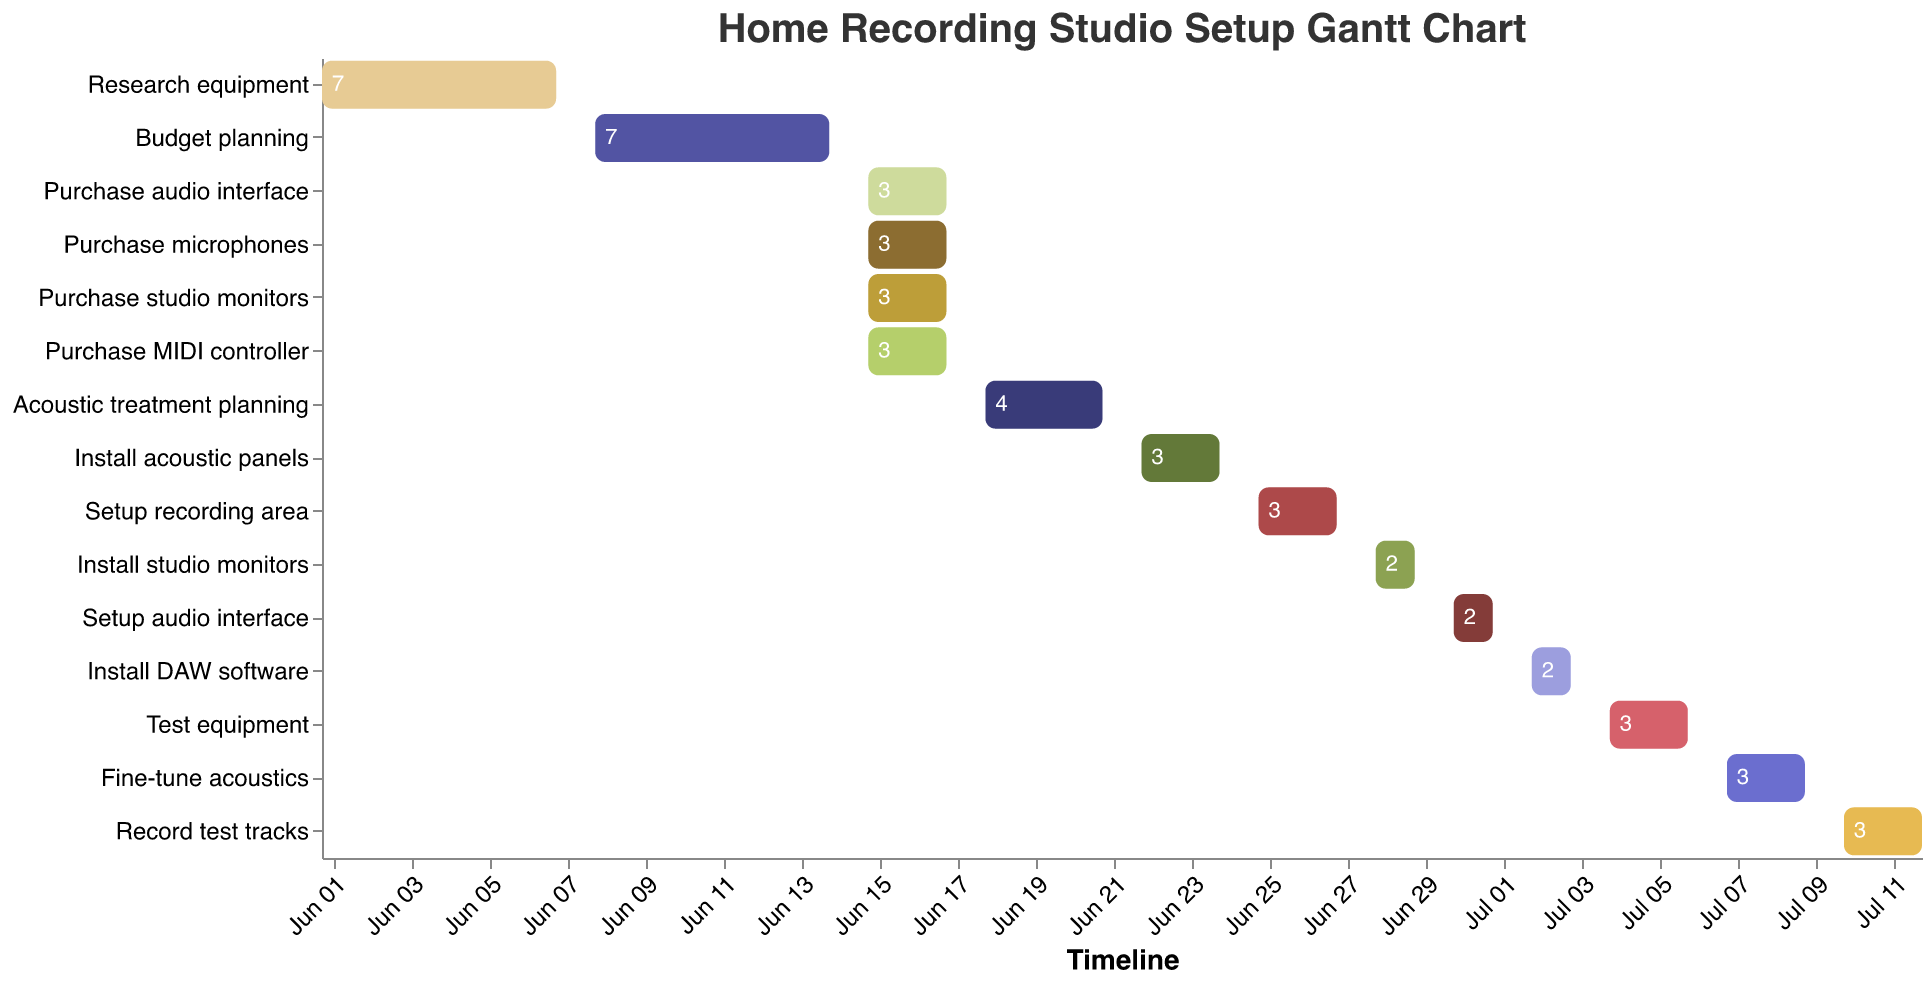How many tasks are scheduled on June 15, 2023? Look for tasks that have a start date of June 15, 2023. There are four tasks with this start date: "Purchase audio interface," "Purchase microphones," "Purchase studio monitors," and "Purchase MIDI controller."
Answer: 4 When does the "Install DAW software" task end? Check the end date for the task labeled "Install DAW software." The end date is July 3, 2023.
Answer: July 3, 2023 Which task has the shortest duration? Identify the task with the smallest duration value. The task "Install studio monitors" and "Setup audio interface" both have the shortest duration of 2 days.
Answer: Install studio monitors, Setup audio interface Which task immediately follows "Research equipment"? Check the start date of the tasks and find the one that starts right after the end date of "Research equipment," which is June 7, 2023. The task "Budget planning" starts immediately after on June 8, 2023.
Answer: Budget planning What is the total duration for setting up the recording area, including all related tasks? Add the durations of "Setup recording area," "Install studio monitors," and "Setup audio interface," which are 3, 2, and 2 days, respectively. 3 + 2 + 2 = 7 days.
Answer: 7 days Which tasks overlap with the "Acoustic treatment planning" task? Identify tasks whose timeframes overlap with the "Acoustic treatment planning" dates of June 18 to June 21. None of the tasks entirely overlap with this period, except for "Install acoustic panels," which starts immediately after on June 22.
Answer: None How many days after the start of "Budget planning" does the "Purchase studio monitors" task begin? "Budget planning" starts on June 8, and "Purchase studio monitors" start on June 15. The difference is 7 days.
Answer: 7 days Are there any tasks that extend into July? If so, which ones? Check if any task's end date is in July. "Setup audio interface," "Install DAW software," "Test equipment," "Fine-tune acoustics," and "Record test tracks" all extend into July.
Answer: Setup audio interface, Install DAW software, Test equipment, Fine-tune acoustics, Record test tracks What is the duration of the "Test equipment" task relative to the "Setup audio interface" task? Find the durations of "Test equipment" (3 days) and "Setup audio interface" (2 days) and compare them. The duration of "Test equipment" is 1 day longer than "Setup audio interface."
Answer: 1 day longer Which tasks are scheduled during the final week of June (June 24-30)? Identify tasks whose timeframes overlap with June 24-30. "Setup recording area," "Install studio monitors," and "Setup audio interface" are scheduled during this period.
Answer: Setup recording area, Install studio monitors, Setup audio interface 